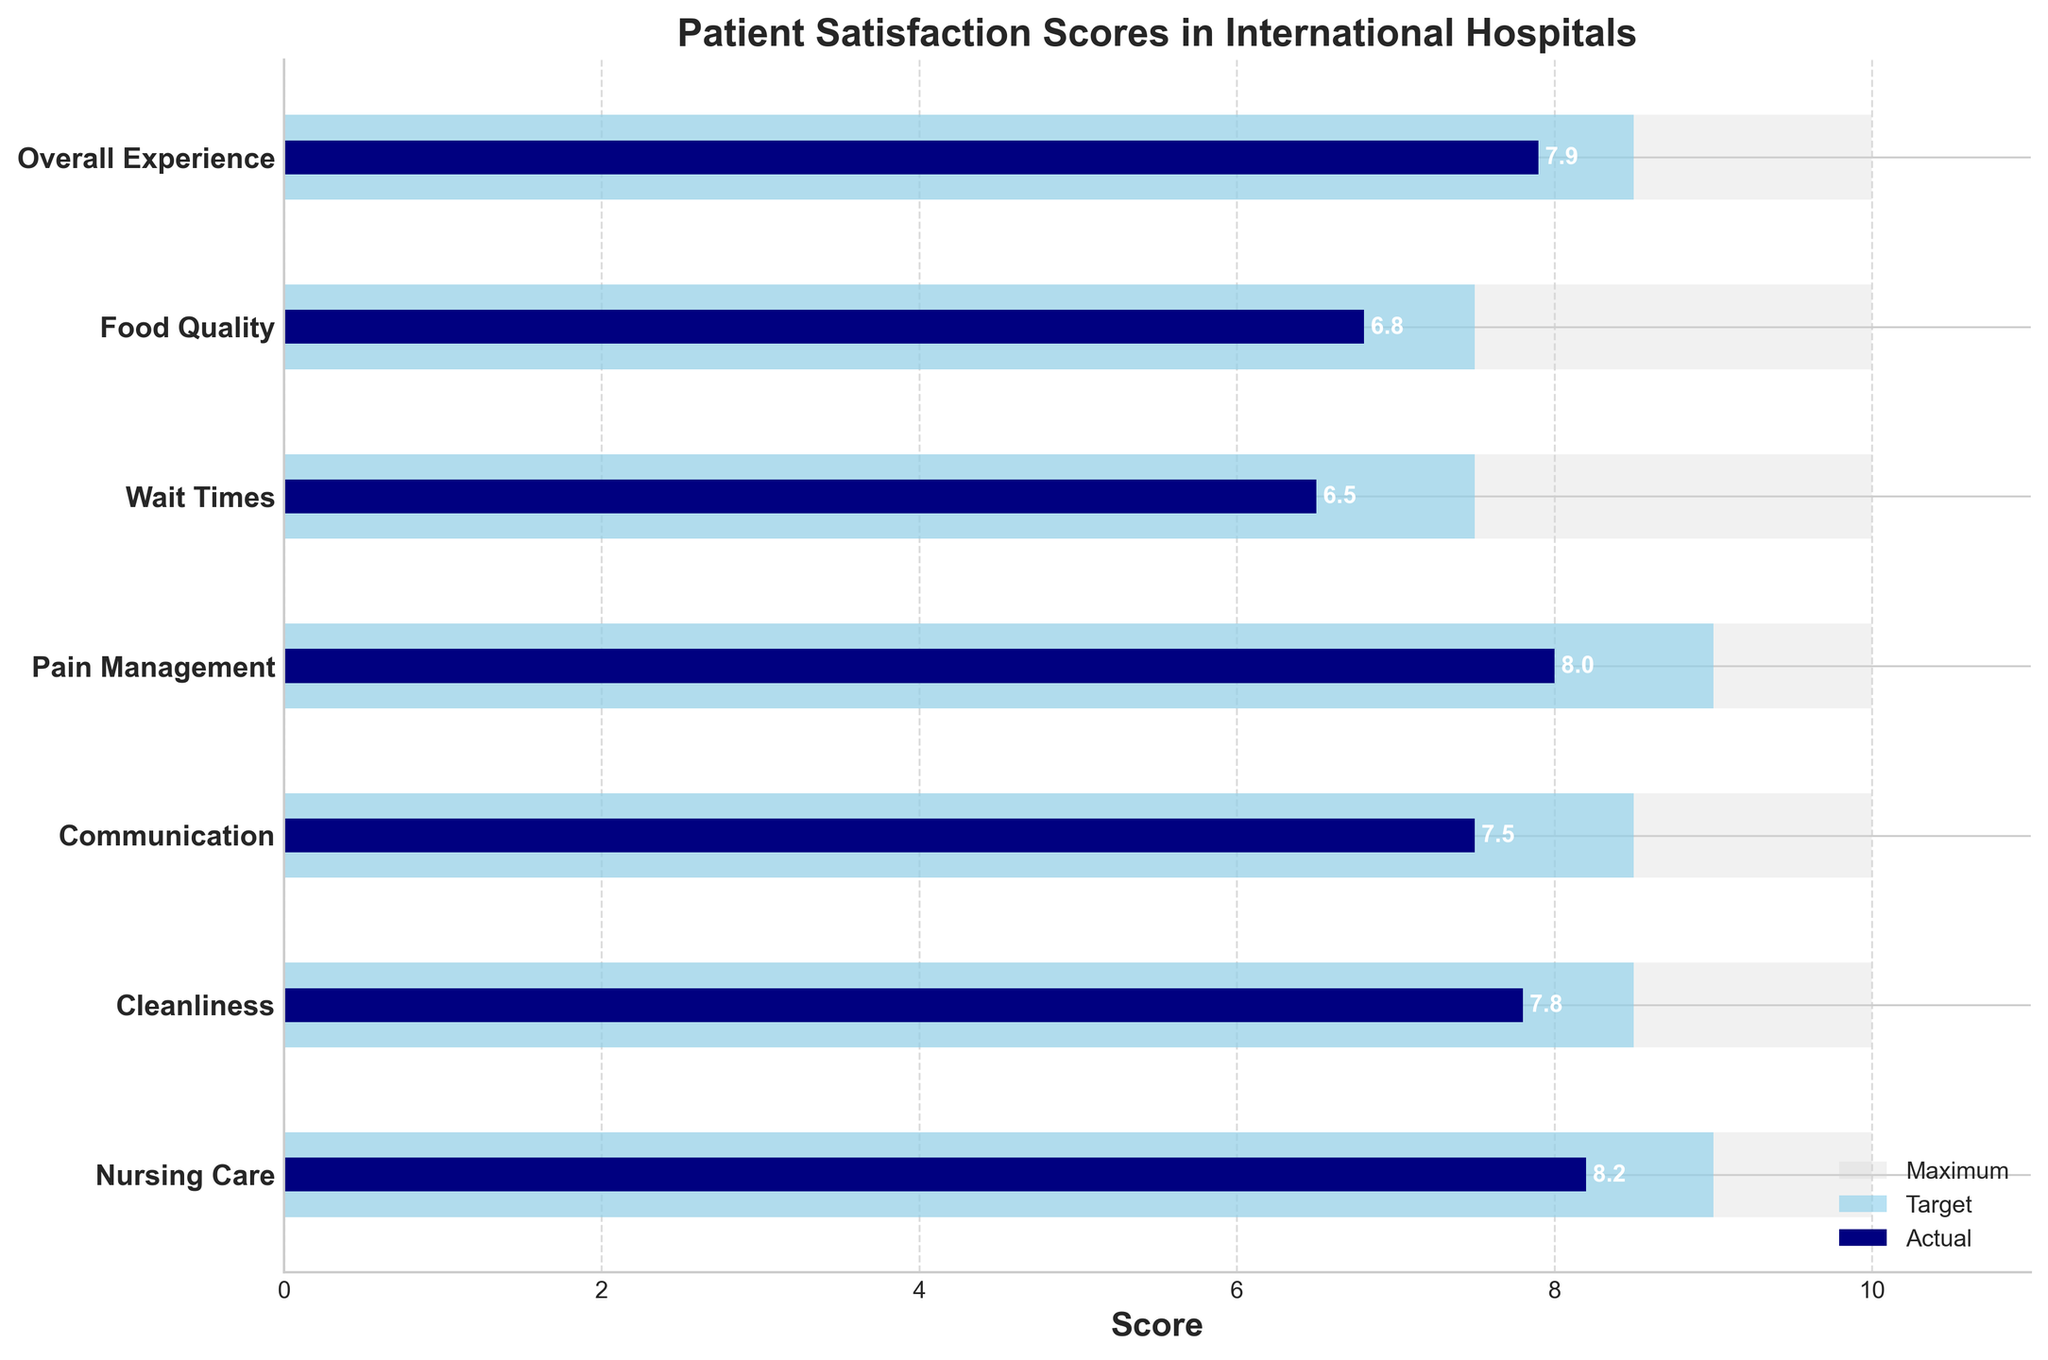What is the title of the chart? The title is at the top of the chart and provides an overview of the data being presented.
Answer: Patient Satisfaction Scores in International Hospitals What color represents the 'Actual' patient satisfaction scores? The colors in the chart help differentiate between 'Maximum', 'Target', and 'Actual' scores. The 'Actual' scores are represented by the darkest color.
Answer: Navy What is the patient satisfaction score for 'Wait Times'? Look at the label 'Wait Times' on the y-axis and then follow it horizontally to the bar representing 'Actual' scores.
Answer: 6.5 Which aspect has the highest 'Actual' patient satisfaction score? Compare the lengths of the 'Actual' bars for all aspects to see which is the longest.
Answer: Nursing Care What is the average 'Target' score across all aspects? Add all the 'Target' scores and divide by the number of aspects: (9.0 + 8.5 + 8.5 + 9.0 + 7.5 + 7.5 + 8.5)/7.
Answer: 8.35 How much lower is the 'Actual' score for 'Communication' compared to its 'Target'? Find the 'Actual' and 'Target' scores for 'Communication' and subtract the 'Actual' from the 'Target': 8.5 - 7.5.
Answer: 1.0 Which aspect shows the greatest difference between 'Actual' and 'Target' scores? Subtract the 'Actual' score from the 'Target' score for each aspect and find the maximum difference. 'Wait Times': 7.5 - 6.5 = 1.0, 'Food Quality': 7.5 - 6.8 = 0.7, etc.
Answer: Communication For which aspect is the 'Actual' score exactly equal to the 'Target' score minus 1? Subtract 1 from the 'Target' score of each aspect and see if it matches the 'Actual' score.
Answer: Pain Management Which aspect has the smallest difference between 'Actual' and 'Target' scores? Calculate the difference between 'Actual' and 'Target' scores for each aspect and identify the smallest one.
Answer: Food Quality What is the total maximum possible score across all aspects? Sum the 'Maximum' scores for all aspects: 10 + 10 + 10 + 10 + 10 + 10 + 10.
Answer: 70 